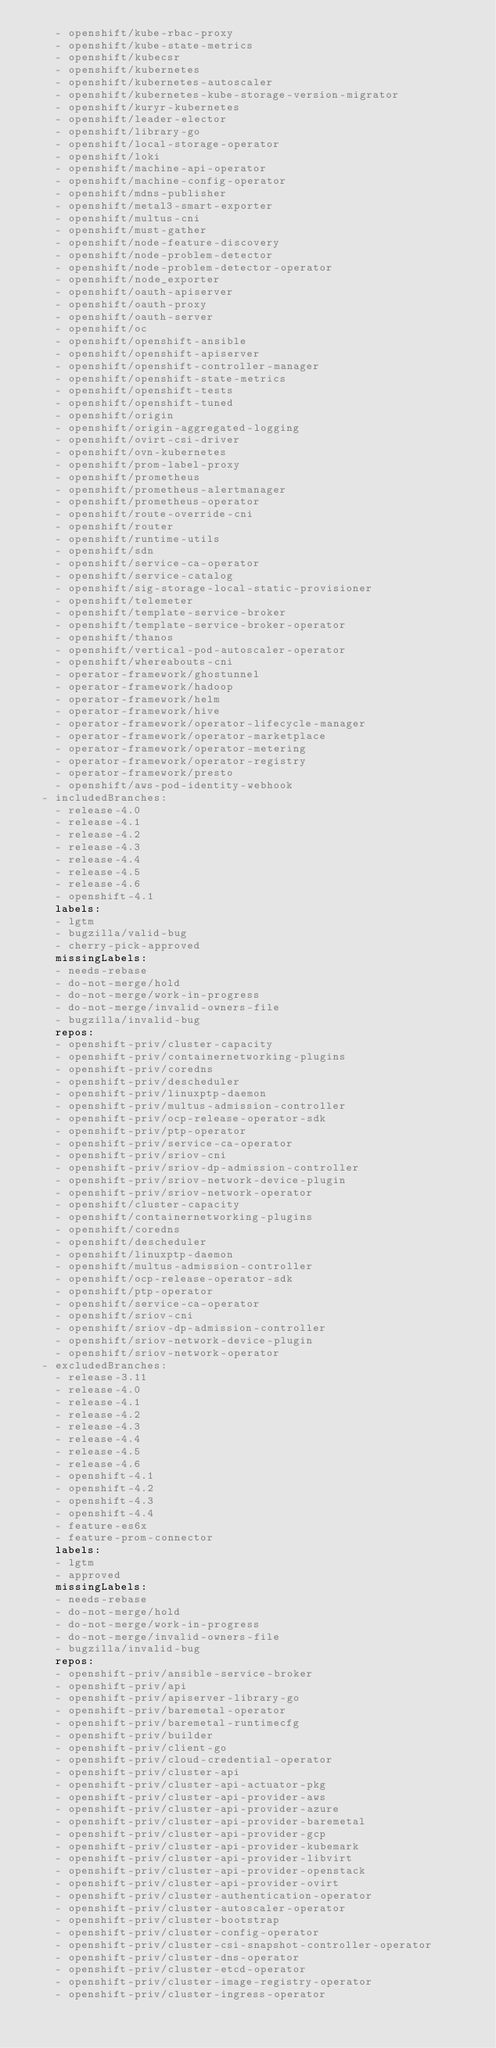<code> <loc_0><loc_0><loc_500><loc_500><_YAML_>    - openshift/kube-rbac-proxy
    - openshift/kube-state-metrics
    - openshift/kubecsr
    - openshift/kubernetes
    - openshift/kubernetes-autoscaler
    - openshift/kubernetes-kube-storage-version-migrator
    - openshift/kuryr-kubernetes
    - openshift/leader-elector
    - openshift/library-go
    - openshift/local-storage-operator
    - openshift/loki
    - openshift/machine-api-operator
    - openshift/machine-config-operator
    - openshift/mdns-publisher
    - openshift/metal3-smart-exporter
    - openshift/multus-cni
    - openshift/must-gather
    - openshift/node-feature-discovery
    - openshift/node-problem-detector
    - openshift/node-problem-detector-operator
    - openshift/node_exporter
    - openshift/oauth-apiserver
    - openshift/oauth-proxy
    - openshift/oauth-server
    - openshift/oc
    - openshift/openshift-ansible
    - openshift/openshift-apiserver
    - openshift/openshift-controller-manager
    - openshift/openshift-state-metrics
    - openshift/openshift-tests
    - openshift/openshift-tuned
    - openshift/origin
    - openshift/origin-aggregated-logging
    - openshift/ovirt-csi-driver
    - openshift/ovn-kubernetes
    - openshift/prom-label-proxy
    - openshift/prometheus
    - openshift/prometheus-alertmanager
    - openshift/prometheus-operator
    - openshift/route-override-cni
    - openshift/router
    - openshift/runtime-utils
    - openshift/sdn
    - openshift/service-ca-operator
    - openshift/service-catalog
    - openshift/sig-storage-local-static-provisioner
    - openshift/telemeter
    - openshift/template-service-broker
    - openshift/template-service-broker-operator
    - openshift/thanos
    - openshift/vertical-pod-autoscaler-operator
    - openshift/whereabouts-cni
    - operator-framework/ghostunnel
    - operator-framework/hadoop
    - operator-framework/helm
    - operator-framework/hive
    - operator-framework/operator-lifecycle-manager
    - operator-framework/operator-marketplace
    - operator-framework/operator-metering
    - operator-framework/operator-registry
    - operator-framework/presto
    - openshift/aws-pod-identity-webhook
  - includedBranches:
    - release-4.0
    - release-4.1
    - release-4.2
    - release-4.3
    - release-4.4
    - release-4.5
    - release-4.6
    - openshift-4.1
    labels:
    - lgtm
    - bugzilla/valid-bug
    - cherry-pick-approved
    missingLabels:
    - needs-rebase
    - do-not-merge/hold
    - do-not-merge/work-in-progress
    - do-not-merge/invalid-owners-file
    - bugzilla/invalid-bug
    repos:
    - openshift-priv/cluster-capacity
    - openshift-priv/containernetworking-plugins
    - openshift-priv/coredns
    - openshift-priv/descheduler
    - openshift-priv/linuxptp-daemon
    - openshift-priv/multus-admission-controller
    - openshift-priv/ocp-release-operator-sdk
    - openshift-priv/ptp-operator
    - openshift-priv/service-ca-operator
    - openshift-priv/sriov-cni
    - openshift-priv/sriov-dp-admission-controller
    - openshift-priv/sriov-network-device-plugin
    - openshift-priv/sriov-network-operator
    - openshift/cluster-capacity
    - openshift/containernetworking-plugins
    - openshift/coredns
    - openshift/descheduler
    - openshift/linuxptp-daemon
    - openshift/multus-admission-controller
    - openshift/ocp-release-operator-sdk
    - openshift/ptp-operator
    - openshift/service-ca-operator
    - openshift/sriov-cni
    - openshift/sriov-dp-admission-controller
    - openshift/sriov-network-device-plugin
    - openshift/sriov-network-operator
  - excludedBranches:
    - release-3.11
    - release-4.0
    - release-4.1
    - release-4.2
    - release-4.3
    - release-4.4
    - release-4.5
    - release-4.6
    - openshift-4.1
    - openshift-4.2
    - openshift-4.3
    - openshift-4.4
    - feature-es6x
    - feature-prom-connector
    labels:
    - lgtm
    - approved
    missingLabels:
    - needs-rebase
    - do-not-merge/hold
    - do-not-merge/work-in-progress
    - do-not-merge/invalid-owners-file
    - bugzilla/invalid-bug
    repos:
    - openshift-priv/ansible-service-broker
    - openshift-priv/api
    - openshift-priv/apiserver-library-go
    - openshift-priv/baremetal-operator
    - openshift-priv/baremetal-runtimecfg
    - openshift-priv/builder
    - openshift-priv/client-go
    - openshift-priv/cloud-credential-operator
    - openshift-priv/cluster-api
    - openshift-priv/cluster-api-actuator-pkg
    - openshift-priv/cluster-api-provider-aws
    - openshift-priv/cluster-api-provider-azure
    - openshift-priv/cluster-api-provider-baremetal
    - openshift-priv/cluster-api-provider-gcp
    - openshift-priv/cluster-api-provider-kubemark
    - openshift-priv/cluster-api-provider-libvirt
    - openshift-priv/cluster-api-provider-openstack
    - openshift-priv/cluster-api-provider-ovirt
    - openshift-priv/cluster-authentication-operator
    - openshift-priv/cluster-autoscaler-operator
    - openshift-priv/cluster-bootstrap
    - openshift-priv/cluster-config-operator
    - openshift-priv/cluster-csi-snapshot-controller-operator
    - openshift-priv/cluster-dns-operator
    - openshift-priv/cluster-etcd-operator
    - openshift-priv/cluster-image-registry-operator
    - openshift-priv/cluster-ingress-operator</code> 